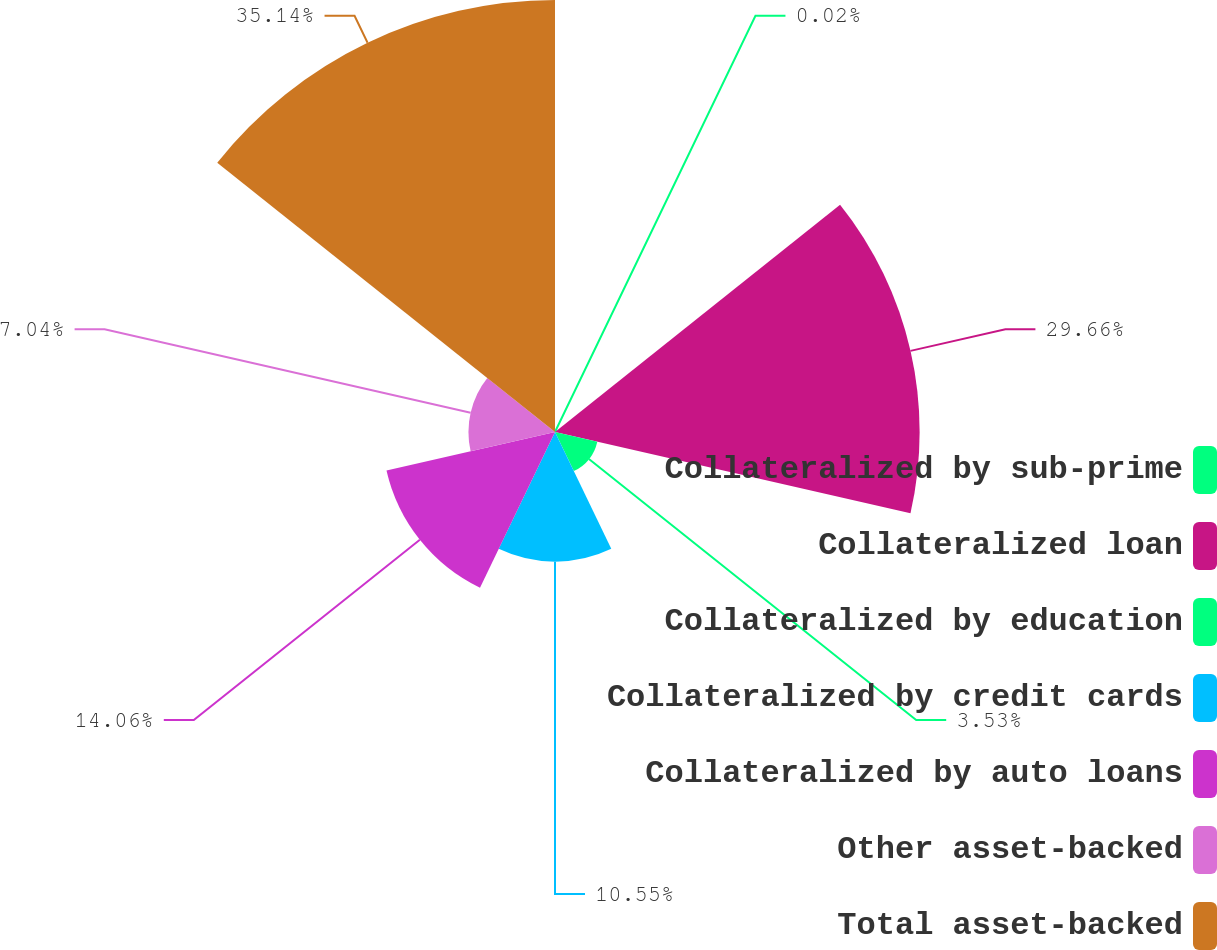<chart> <loc_0><loc_0><loc_500><loc_500><pie_chart><fcel>Collateralized by sub-prime<fcel>Collateralized loan<fcel>Collateralized by education<fcel>Collateralized by credit cards<fcel>Collateralized by auto loans<fcel>Other asset-backed<fcel>Total asset-backed<nl><fcel>0.02%<fcel>29.66%<fcel>3.53%<fcel>10.55%<fcel>14.06%<fcel>7.04%<fcel>35.14%<nl></chart> 